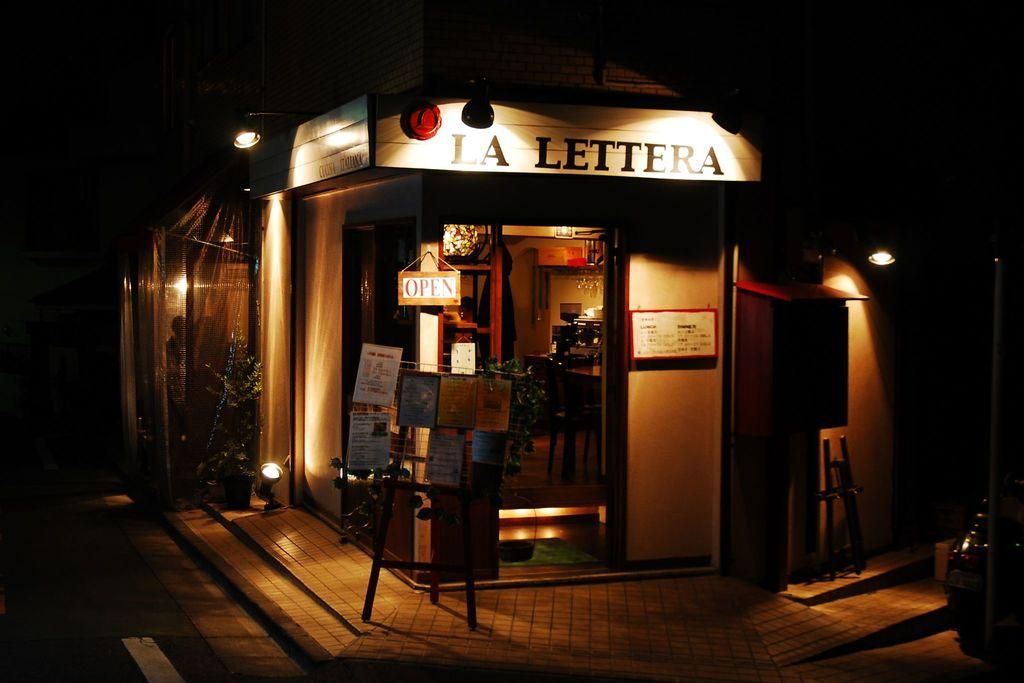<image>
Offer a succinct explanation of the picture presented. The corner of a street with a store name La Lettera which is currently open 